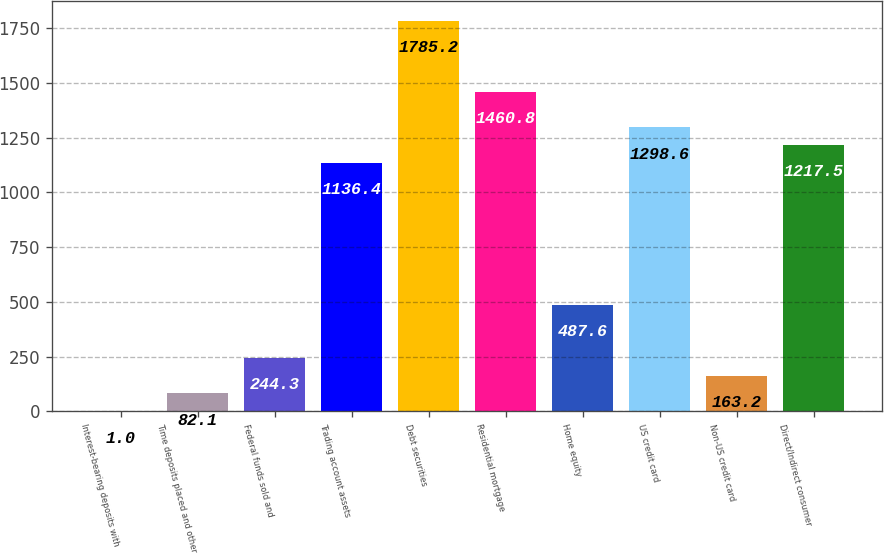Convert chart to OTSL. <chart><loc_0><loc_0><loc_500><loc_500><bar_chart><fcel>Interest-bearing deposits with<fcel>Time deposits placed and other<fcel>Federal funds sold and<fcel>Trading account assets<fcel>Debt securities<fcel>Residential mortgage<fcel>Home equity<fcel>US credit card<fcel>Non-US credit card<fcel>Direct/Indirect consumer<nl><fcel>1<fcel>82.1<fcel>244.3<fcel>1136.4<fcel>1785.2<fcel>1460.8<fcel>487.6<fcel>1298.6<fcel>163.2<fcel>1217.5<nl></chart> 